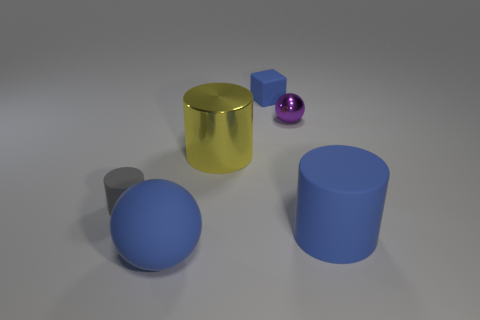Are there any other things that have the same shape as the tiny gray matte object?
Offer a very short reply. Yes. Do the small blue matte object and the tiny metal object have the same shape?
Your answer should be compact. No. Are there the same number of large blue matte cylinders that are in front of the tiny gray rubber thing and matte things in front of the big rubber sphere?
Ensure brevity in your answer.  No. What number of other objects are the same material as the yellow thing?
Give a very brief answer. 1. How many large things are either purple rubber cubes or blue objects?
Give a very brief answer. 2. Are there an equal number of objects left of the tiny blue block and tiny cylinders?
Your answer should be compact. No. There is a matte cylinder that is to the right of the gray cylinder; are there any matte spheres that are to the right of it?
Provide a succinct answer. No. How many other things are there of the same color as the metal ball?
Your answer should be very brief. 0. What is the color of the tiny metallic ball?
Offer a very short reply. Purple. What is the size of the blue rubber thing that is to the right of the yellow object and in front of the small rubber cylinder?
Offer a terse response. Large. 